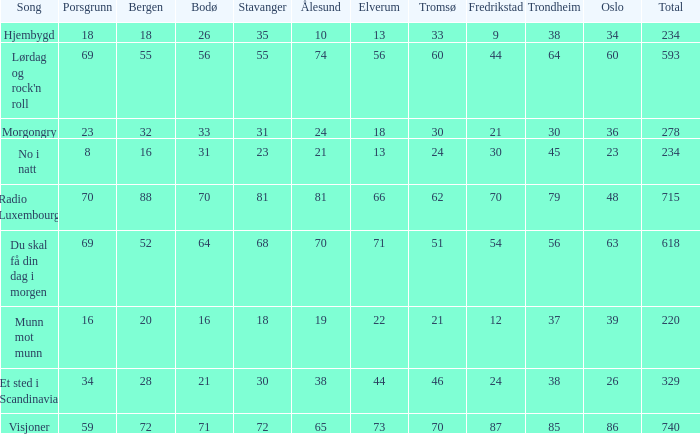What is the lowest total? 220.0. 